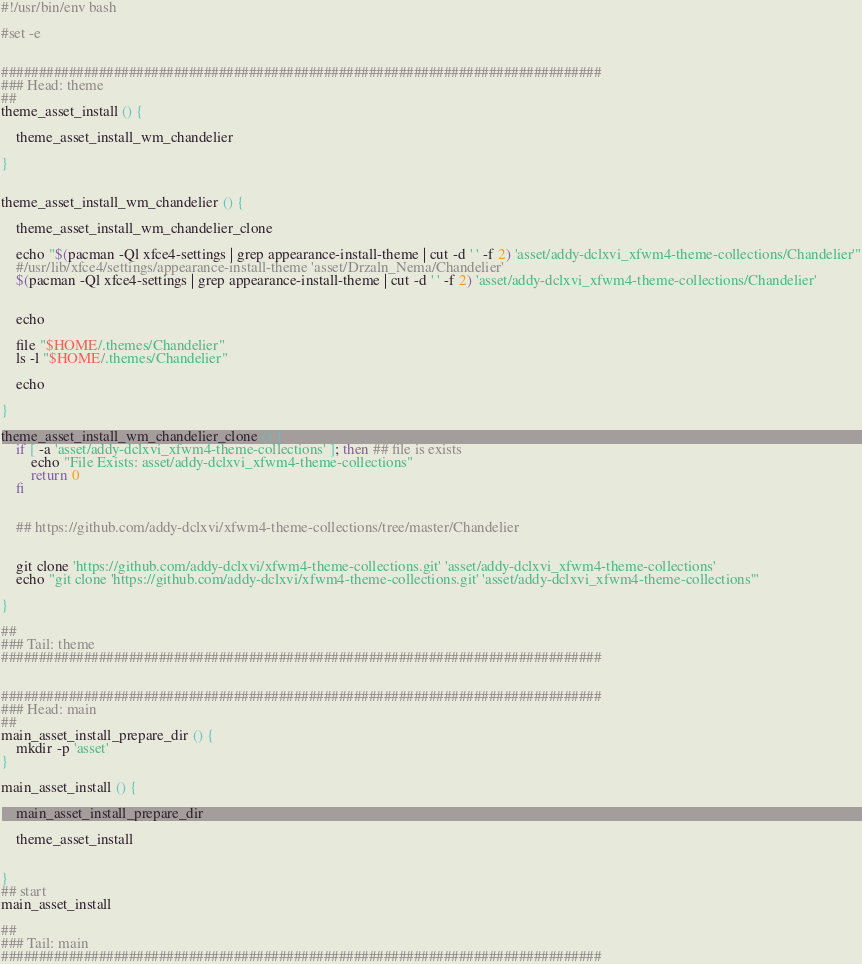<code> <loc_0><loc_0><loc_500><loc_500><_Bash_>#!/usr/bin/env bash

#set -e


################################################################################
### Head: theme
##
theme_asset_install () {

	theme_asset_install_wm_chandelier

}


theme_asset_install_wm_chandelier () {

	theme_asset_install_wm_chandelier_clone

	echo "$(pacman -Ql xfce4-settings | grep appearance-install-theme | cut -d ' ' -f 2) 'asset/addy-dclxvi_xfwm4-theme-collections/Chandelier'"
	#/usr/lib/xfce4/settings/appearance-install-theme 'asset/Drzaln_Nema/Chandelier'
	$(pacman -Ql xfce4-settings | grep appearance-install-theme | cut -d ' ' -f 2) 'asset/addy-dclxvi_xfwm4-theme-collections/Chandelier'


	echo

	file "$HOME/.themes/Chandelier"
	ls -l "$HOME/.themes/Chandelier"

	echo

}

theme_asset_install_wm_chandelier_clone () {
	if [ -a 'asset/addy-dclxvi_xfwm4-theme-collections' ]; then ## file is exists
		echo "File Exists: asset/addy-dclxvi_xfwm4-theme-collections"
		return 0
	fi


	## https://github.com/addy-dclxvi/xfwm4-theme-collections/tree/master/Chandelier


	git clone 'https://github.com/addy-dclxvi/xfwm4-theme-collections.git' 'asset/addy-dclxvi_xfwm4-theme-collections'
	echo "git clone 'https://github.com/addy-dclxvi/xfwm4-theme-collections.git' 'asset/addy-dclxvi_xfwm4-theme-collections'"

}

##
### Tail: theme
################################################################################


################################################################################
### Head: main
##
main_asset_install_prepare_dir () {
	mkdir -p 'asset'
}

main_asset_install () {

	main_asset_install_prepare_dir

	theme_asset_install


}
## start
main_asset_install

##
### Tail: main
################################################################################
</code> 